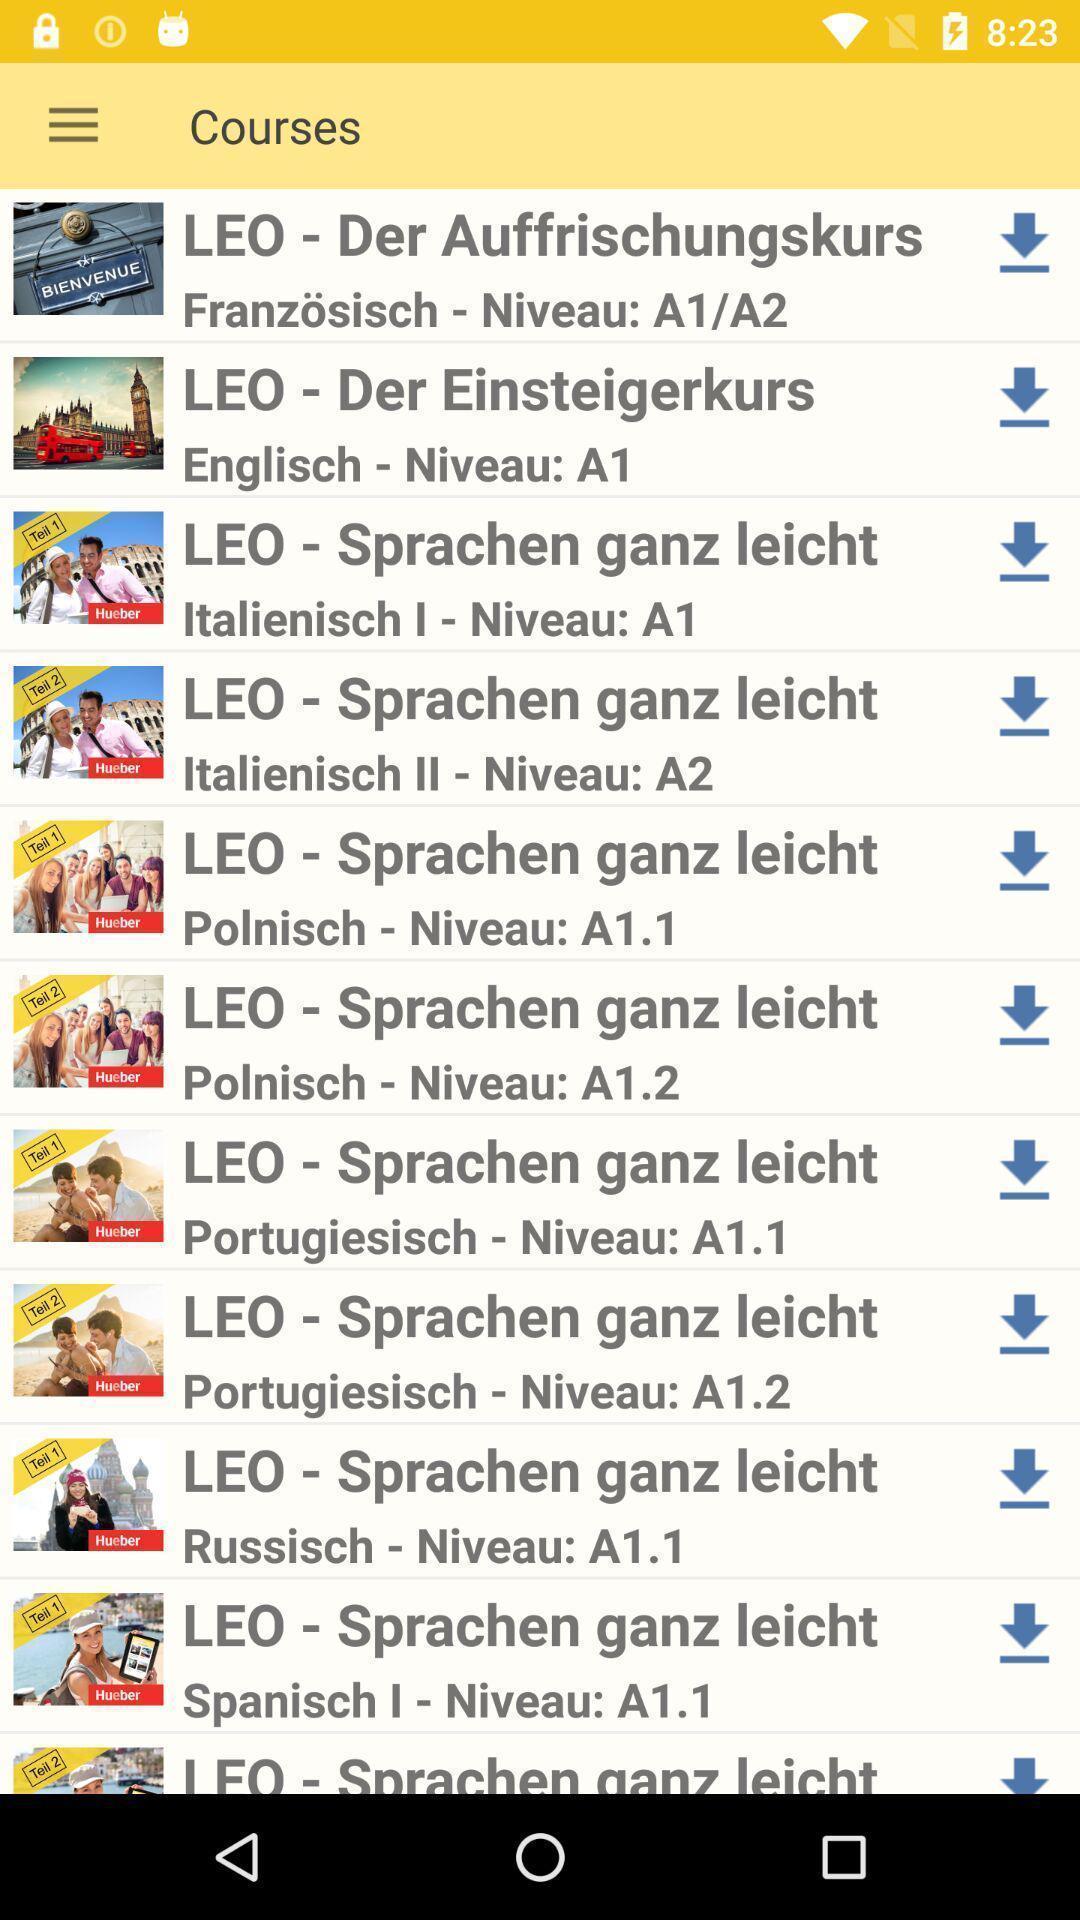Describe the key features of this screenshot. Various types of courses in the application in mobile. 